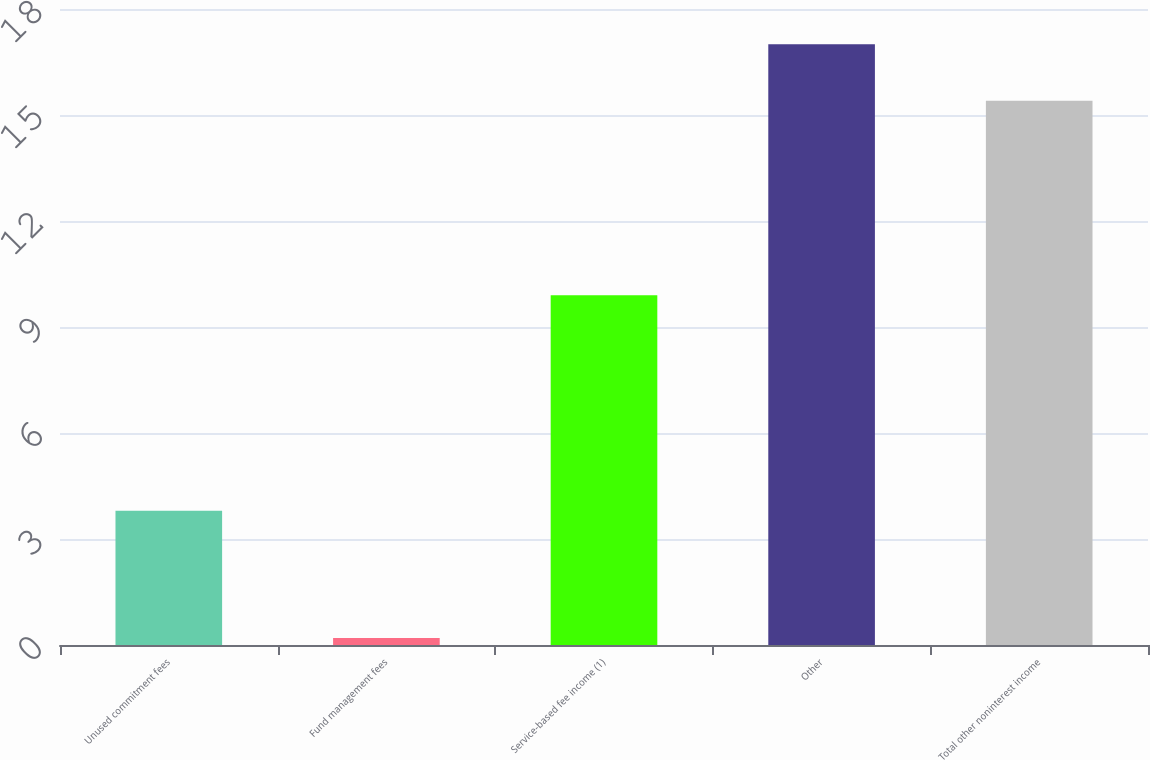Convert chart. <chart><loc_0><loc_0><loc_500><loc_500><bar_chart><fcel>Unused commitment fees<fcel>Fund management fees<fcel>Service-based fee income (1)<fcel>Other<fcel>Total other noninterest income<nl><fcel>3.8<fcel>0.2<fcel>9.9<fcel>17<fcel>15.4<nl></chart> 